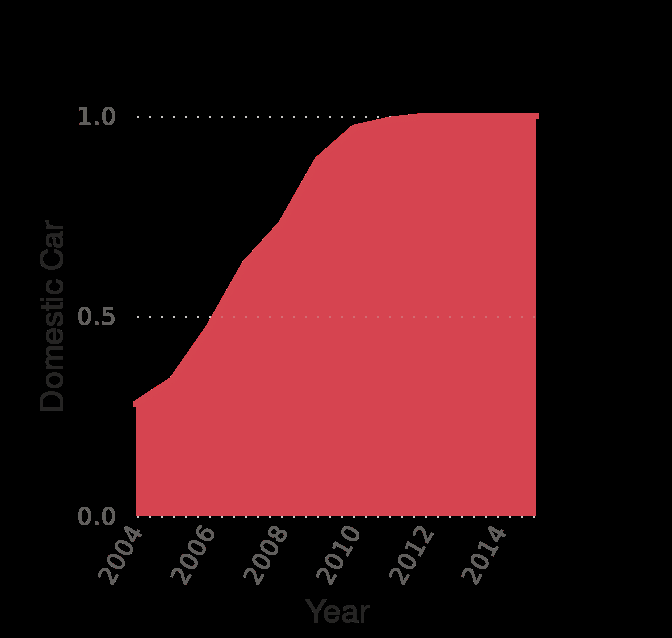<image>
please describe the details of the chart This is a area chart called Penetration rate of side airbags in all cars in the United States from 2004 to 2015 , by origin. Domestic Car is measured on the y-axis. A linear scale with a minimum of 2004 and a maximum of 2014 can be found along the x-axis, labeled Year. What has been the trend of the penetration rate from 2004 to 2012?  The penetration rate has increased steadily during that period. 